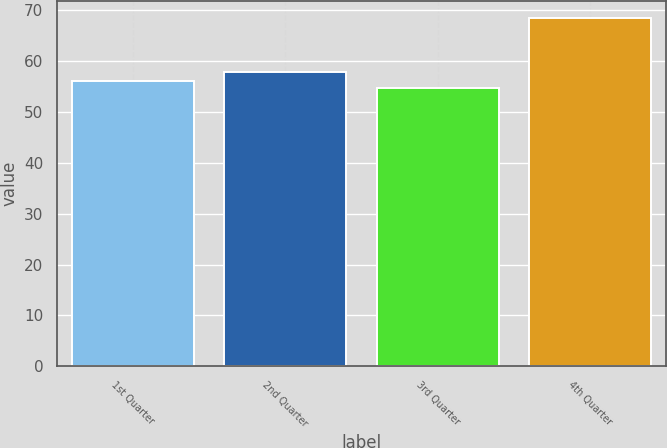Convert chart. <chart><loc_0><loc_0><loc_500><loc_500><bar_chart><fcel>1st Quarter<fcel>2nd Quarter<fcel>3rd Quarter<fcel>4th Quarter<nl><fcel>56.01<fcel>57.84<fcel>54.64<fcel>68.31<nl></chart> 